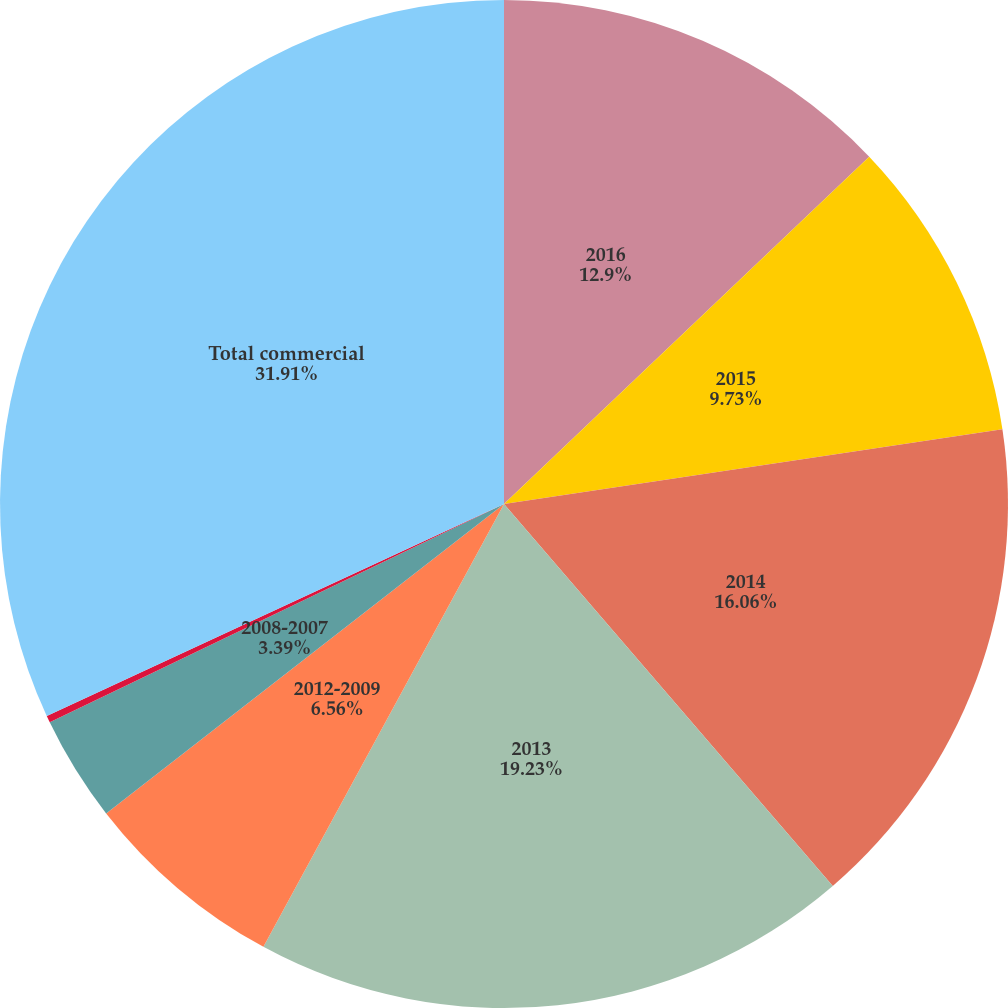Convert chart to OTSL. <chart><loc_0><loc_0><loc_500><loc_500><pie_chart><fcel>2016<fcel>2015<fcel>2014<fcel>2013<fcel>2012-2009<fcel>2008-2007<fcel>2006 & Prior<fcel>Total commercial<nl><fcel>12.9%<fcel>9.73%<fcel>16.06%<fcel>19.23%<fcel>6.56%<fcel>3.39%<fcel>0.22%<fcel>31.91%<nl></chart> 